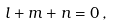Convert formula to latex. <formula><loc_0><loc_0><loc_500><loc_500>l + m + n = 0 \, ,</formula> 